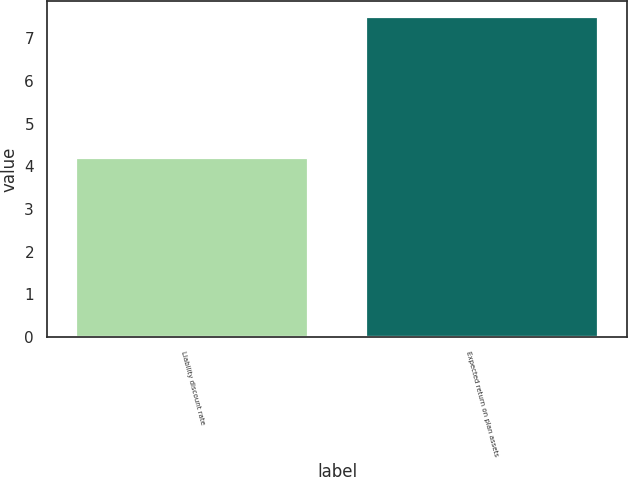Convert chart to OTSL. <chart><loc_0><loc_0><loc_500><loc_500><bar_chart><fcel>Liability discount rate<fcel>Expected return on plan assets<nl><fcel>4.2<fcel>7.5<nl></chart> 